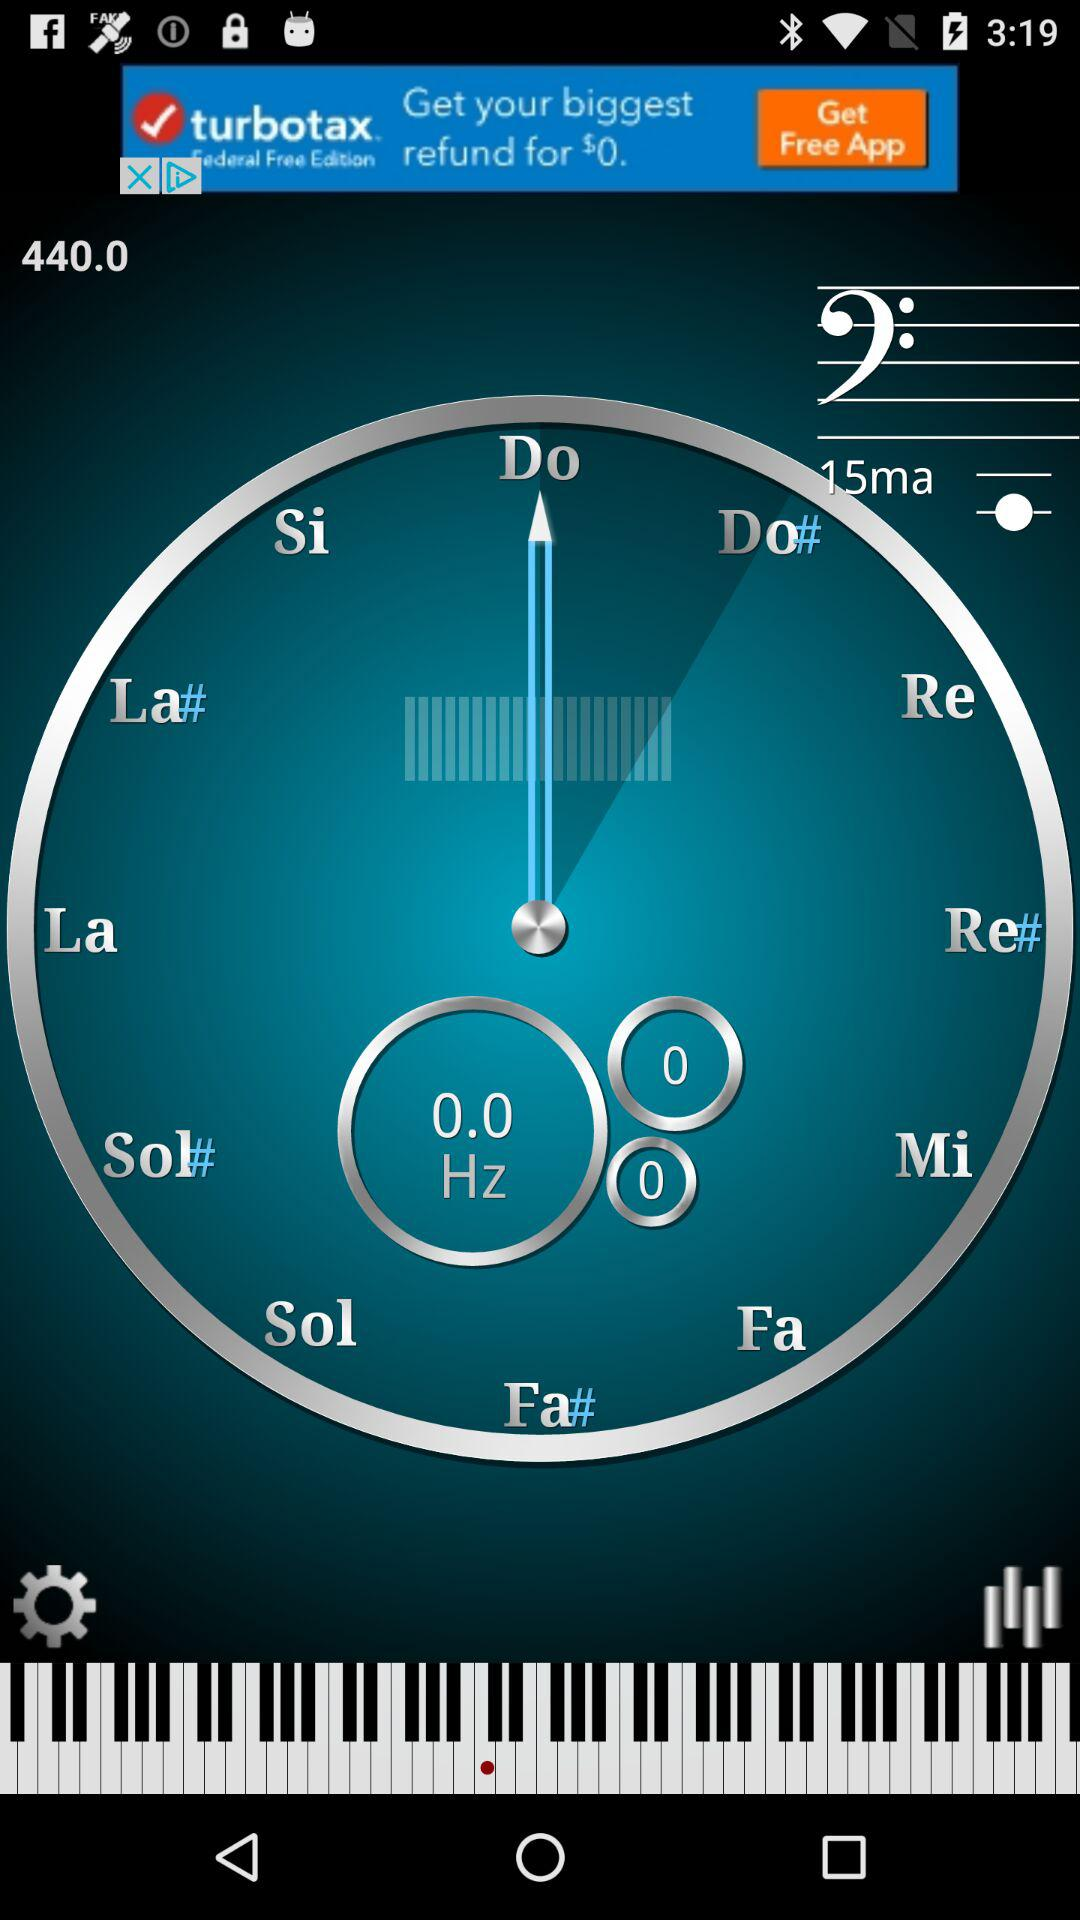How many notes are there in the scale?
Answer the question using a single word or phrase. 12 